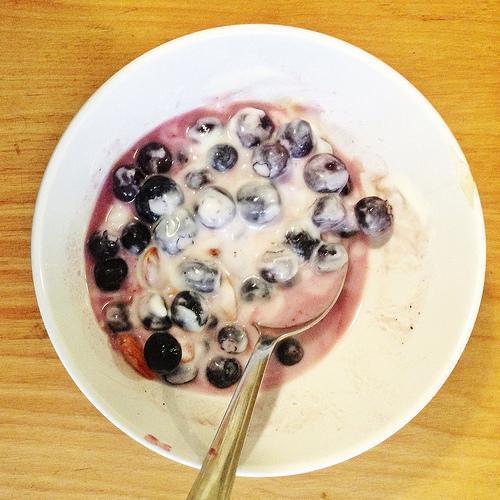How many spoons are there?
Give a very brief answer. 1. How many plates are on the table?
Give a very brief answer. 1. 